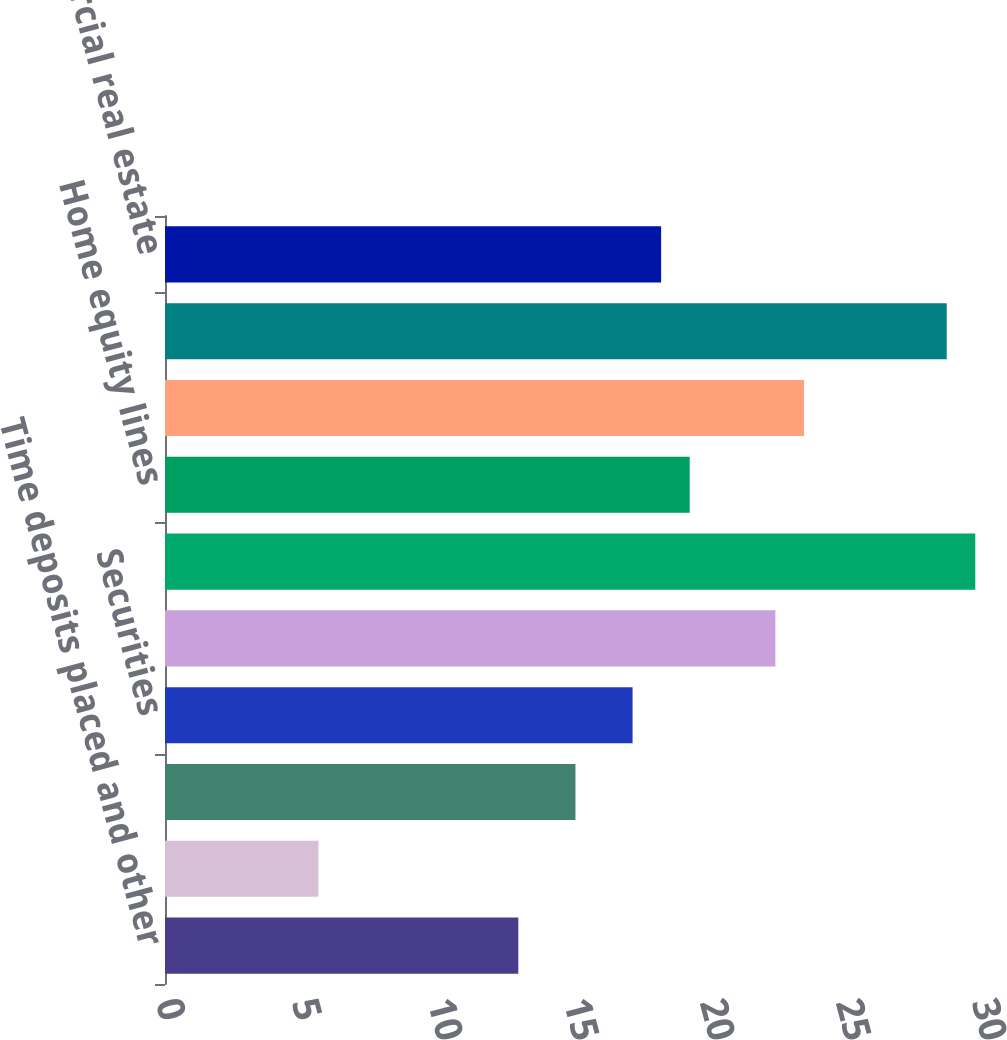Convert chart to OTSL. <chart><loc_0><loc_0><loc_500><loc_500><bar_chart><fcel>Time deposits placed and other<fcel>Federal funds sold and<fcel>Trading account assets<fcel>Securities<fcel>Residential mortgage<fcel>Credit card<fcel>Home equity lines<fcel>Direct/Indirect consumer<fcel>Other consumer (2)<fcel>Commercial real estate<nl><fcel>12.99<fcel>5.64<fcel>15.09<fcel>17.19<fcel>22.44<fcel>29.79<fcel>19.29<fcel>23.49<fcel>28.74<fcel>18.24<nl></chart> 